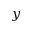<formula> <loc_0><loc_0><loc_500><loc_500>y</formula> 